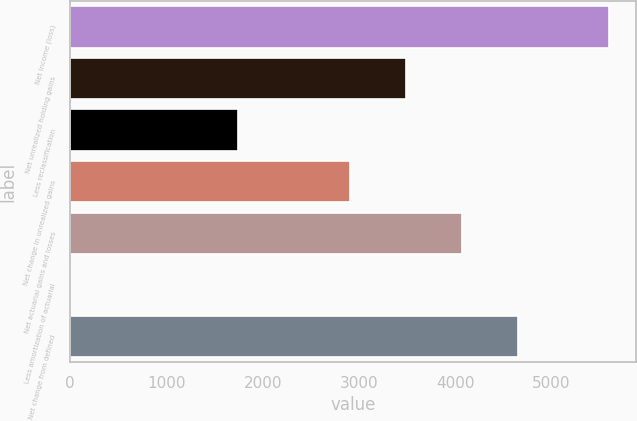<chart> <loc_0><loc_0><loc_500><loc_500><bar_chart><fcel>Net income (loss)<fcel>Net unrealized holding gains<fcel>Less reclassification<fcel>Net change in unrealized gains<fcel>Net actuarial gains and losses<fcel>Less amortization of actuarial<fcel>Net change from defined<nl><fcel>5596<fcel>3493.4<fcel>1747.7<fcel>2911.5<fcel>4075.3<fcel>2<fcel>4657.2<nl></chart> 